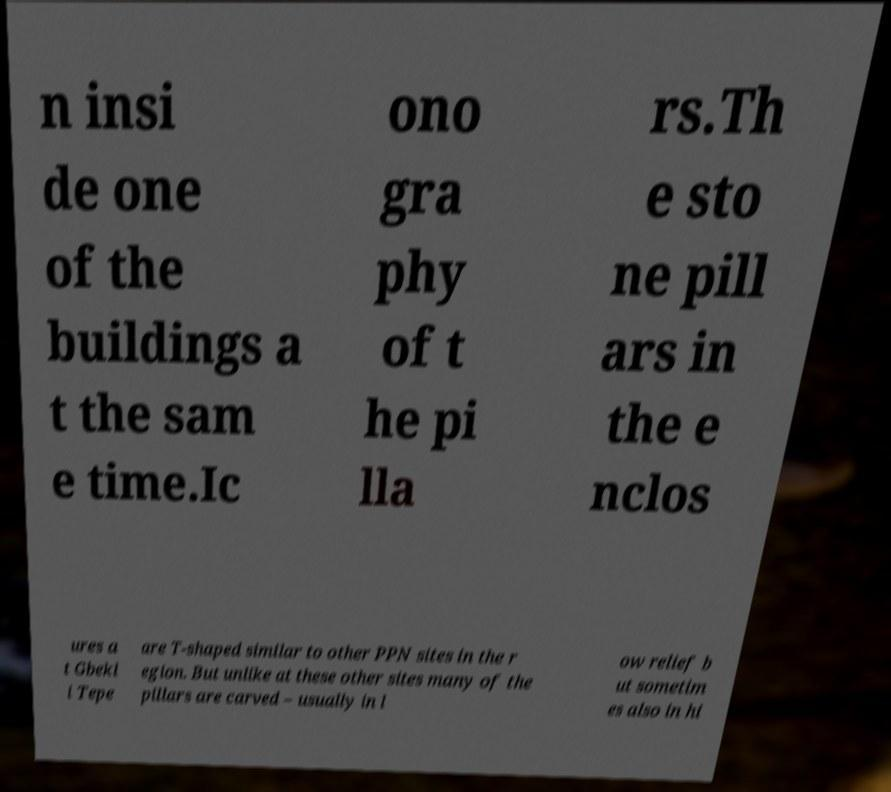There's text embedded in this image that I need extracted. Can you transcribe it verbatim? n insi de one of the buildings a t the sam e time.Ic ono gra phy of t he pi lla rs.Th e sto ne pill ars in the e nclos ures a t Gbekl i Tepe are T-shaped similar to other PPN sites in the r egion. But unlike at these other sites many of the pillars are carved – usually in l ow relief b ut sometim es also in hi 